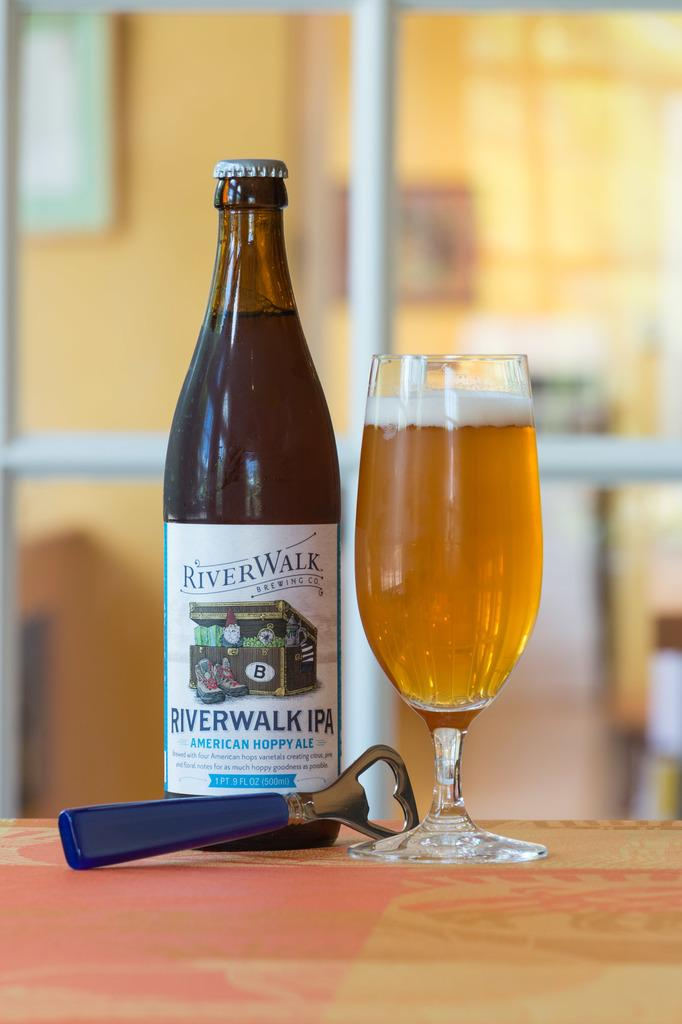Provide a one-sentence caption for the provided image. A bottle of River Walk IPA stands beside a full glass with a bottle opener. 